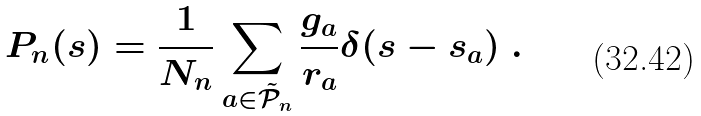Convert formula to latex. <formula><loc_0><loc_0><loc_500><loc_500>P _ { n } ( s ) = \frac { 1 } { N _ { n } } \sum _ { a \in \tilde { \mathcal { P } } _ { n } } \frac { g _ { a } } { r _ { a } } \delta ( s - s _ { a } ) \ .</formula> 